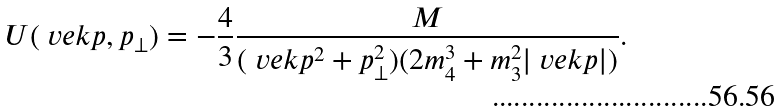<formula> <loc_0><loc_0><loc_500><loc_500>U ( \ v e k { p } , p _ { \perp } ) = - \frac { 4 } { 3 } \frac { M } { ( \ v e k { p } ^ { 2 } + p _ { \perp } ^ { 2 } ) ( 2 m _ { 4 } ^ { 3 } + m _ { 3 } ^ { 2 } | \ v e k { p } | ) } .</formula> 